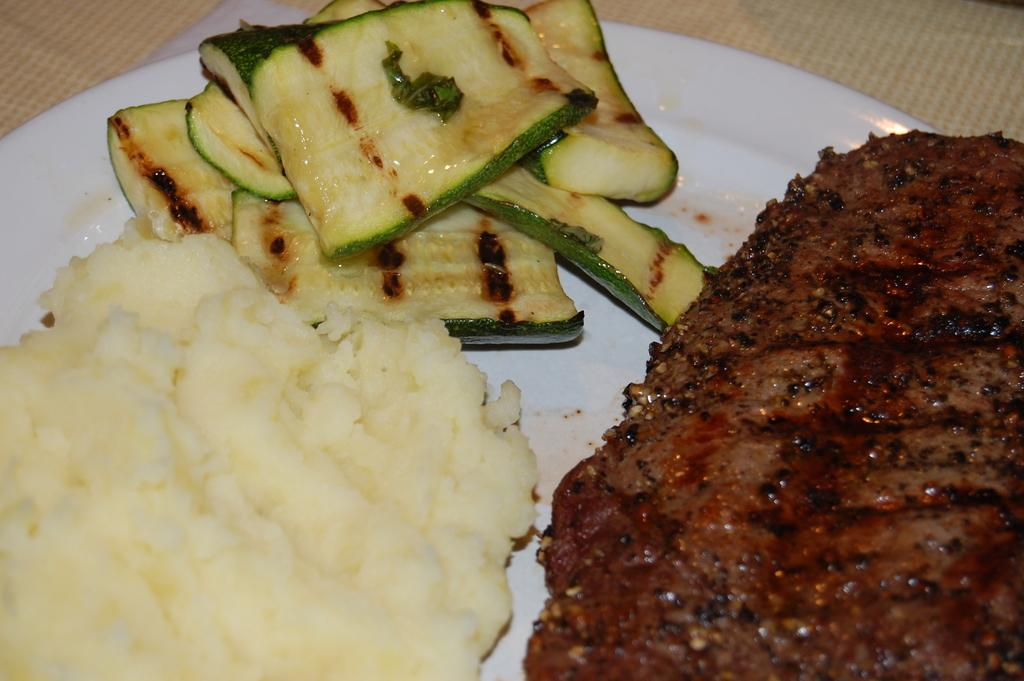What type of food is visible on the plate in the image? There are vegetables pieces on a plate in the image. Are there any other food items on the plate? Yes, there are other food items on the plate. What color is the plate in the image? The plate is white in color. What is the color of the background in the image? The background of the image is white. What type of sweater is being used to serve the food in the image? There is no sweater present in the image; the food is served on a plate. 